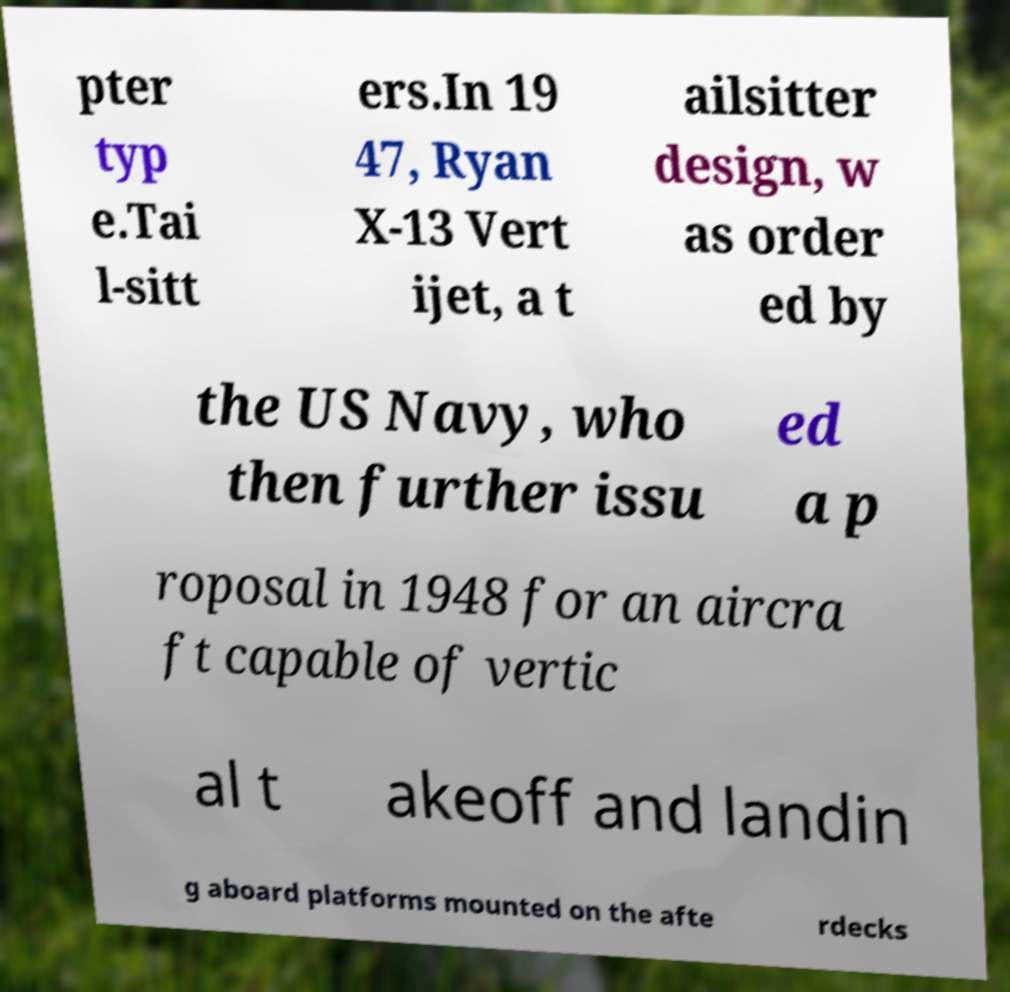Can you read and provide the text displayed in the image?This photo seems to have some interesting text. Can you extract and type it out for me? pter typ e.Tai l-sitt ers.In 19 47, Ryan X-13 Vert ijet, a t ailsitter design, w as order ed by the US Navy, who then further issu ed a p roposal in 1948 for an aircra ft capable of vertic al t akeoff and landin g aboard platforms mounted on the afte rdecks 